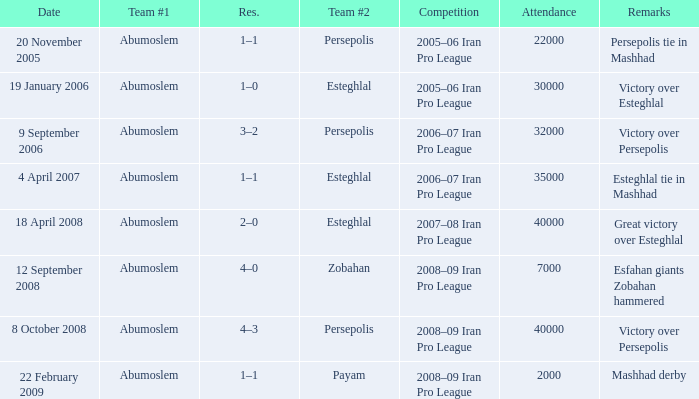What day had an attendance of 22,000? 20 November 2005. 